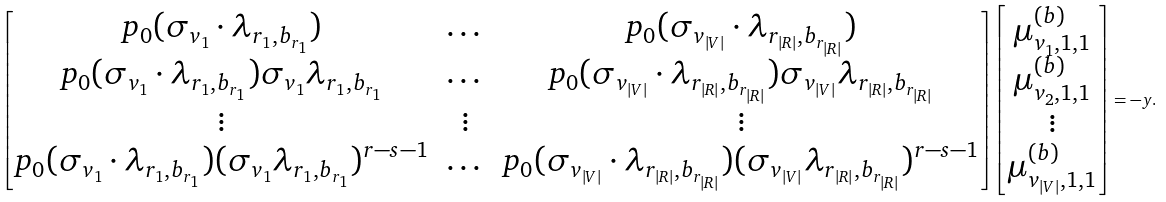<formula> <loc_0><loc_0><loc_500><loc_500>\begin{bmatrix} p _ { 0 } ( \sigma _ { v _ { 1 } } \cdot \lambda _ { r _ { 1 } , b _ { r _ { 1 } } } ) & \dots & p _ { 0 } ( \sigma _ { v _ { | V | } } \cdot \lambda _ { r _ { | R | } , b _ { r _ { | R | } } } ) \\ p _ { 0 } ( \sigma _ { v _ { 1 } } \cdot \lambda _ { r _ { 1 } , b _ { r _ { 1 } } } ) \sigma _ { v _ { 1 } } \lambda _ { r _ { 1 } , b _ { r _ { 1 } } } & \dots & p _ { 0 } ( \sigma _ { v _ { | V | } } \cdot \lambda _ { r _ { | R | } , b _ { r _ { | R | } } } ) \sigma _ { v _ { | V | } } \lambda _ { r _ { | R | } , b _ { r _ { | R | } } } \\ \vdots & \vdots & \vdots \\ p _ { 0 } ( \sigma _ { v _ { 1 } } \cdot \lambda _ { r _ { 1 } , b _ { r _ { 1 } } } ) ( \sigma _ { v _ { 1 } } \lambda _ { r _ { 1 } , b _ { r _ { 1 } } } ) ^ { r - s - 1 } & \dots & p _ { 0 } ( \sigma _ { v _ { | V | } } \cdot \lambda _ { r _ { | R | } , b _ { r _ { | R | } } } ) ( \sigma _ { v _ { | V | } } \lambda _ { r _ { | R | } , b _ { r _ { | R | } } } ) ^ { r - s - 1 } \end{bmatrix} \begin{bmatrix} \mu _ { v _ { 1 } , 1 , 1 } ^ { ( b ) } \\ \mu _ { v _ { 2 } , 1 , 1 } ^ { ( b ) } \\ \vdots \\ \mu _ { v _ { | V | } , 1 , 1 } ^ { ( b ) } \end{bmatrix} = - y .</formula> 